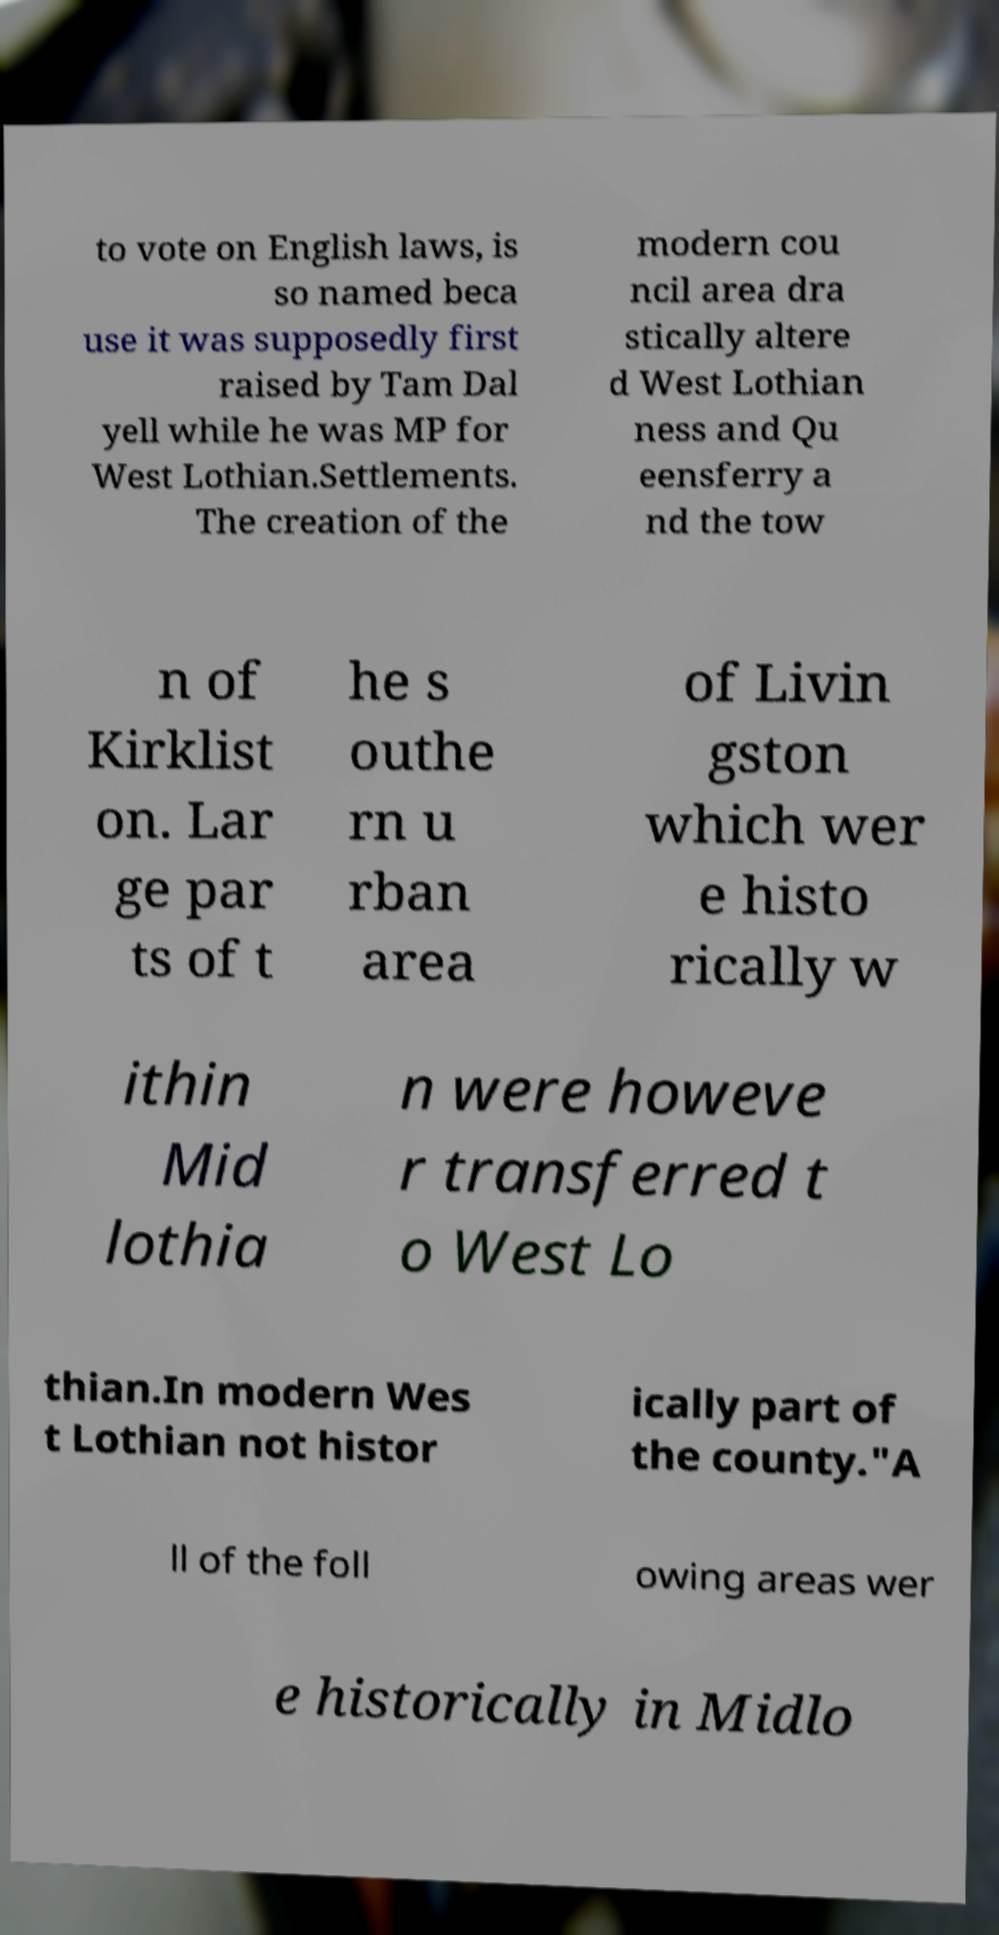Could you assist in decoding the text presented in this image and type it out clearly? to vote on English laws, is so named beca use it was supposedly first raised by Tam Dal yell while he was MP for West Lothian.Settlements. The creation of the modern cou ncil area dra stically altere d West Lothian ness and Qu eensferry a nd the tow n of Kirklist on. Lar ge par ts of t he s outhe rn u rban area of Livin gston which wer e histo rically w ithin Mid lothia n were howeve r transferred t o West Lo thian.In modern Wes t Lothian not histor ically part of the county."A ll of the foll owing areas wer e historically in Midlo 